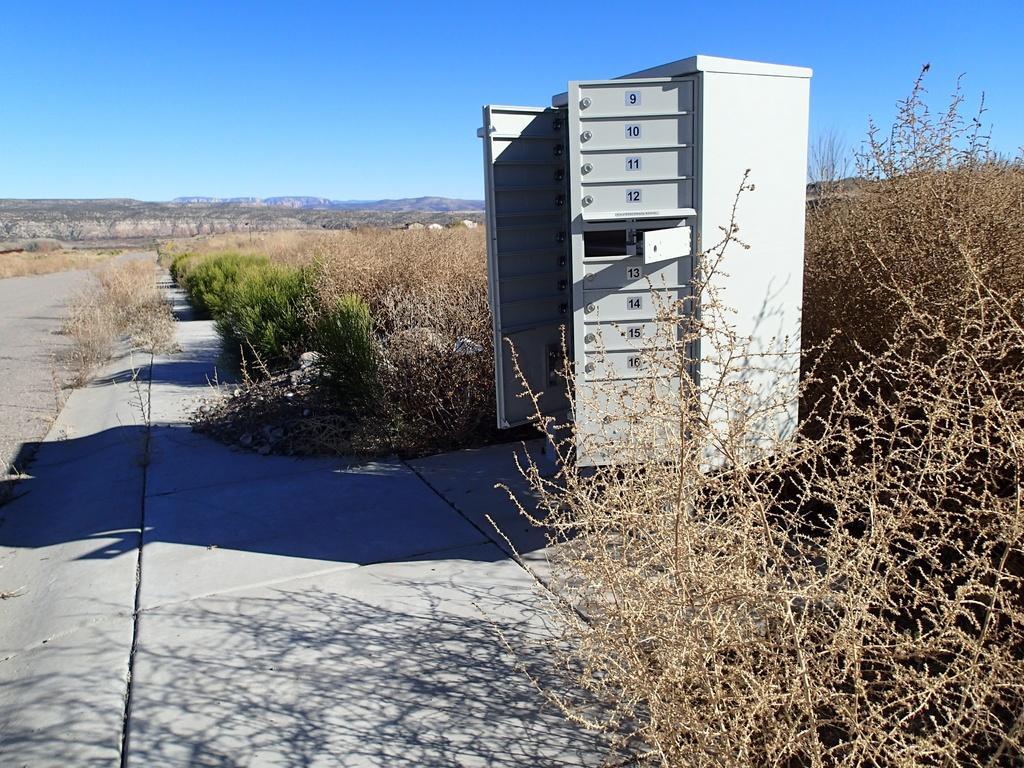Please provide a concise description of this image. In this image I can see plants in green color. I can also see few dried plants. Background I can see sky in blue color, and I can see an iron box. 